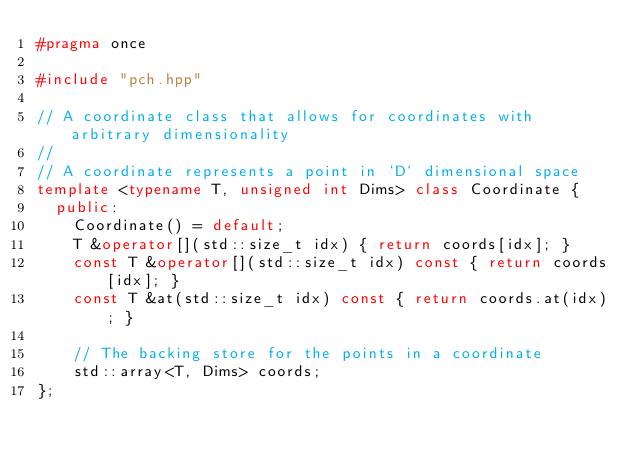<code> <loc_0><loc_0><loc_500><loc_500><_C++_>#pragma once

#include "pch.hpp"

// A coordinate class that allows for coordinates with arbitrary dimensionality
//
// A coordinate represents a point in `D` dimensional space
template <typename T, unsigned int Dims> class Coordinate {
  public:
    Coordinate() = default;
    T &operator[](std::size_t idx) { return coords[idx]; }
    const T &operator[](std::size_t idx) const { return coords[idx]; }
    const T &at(std::size_t idx) const { return coords.at(idx); }

    // The backing store for the points in a coordinate
    std::array<T, Dims> coords;
};
</code> 